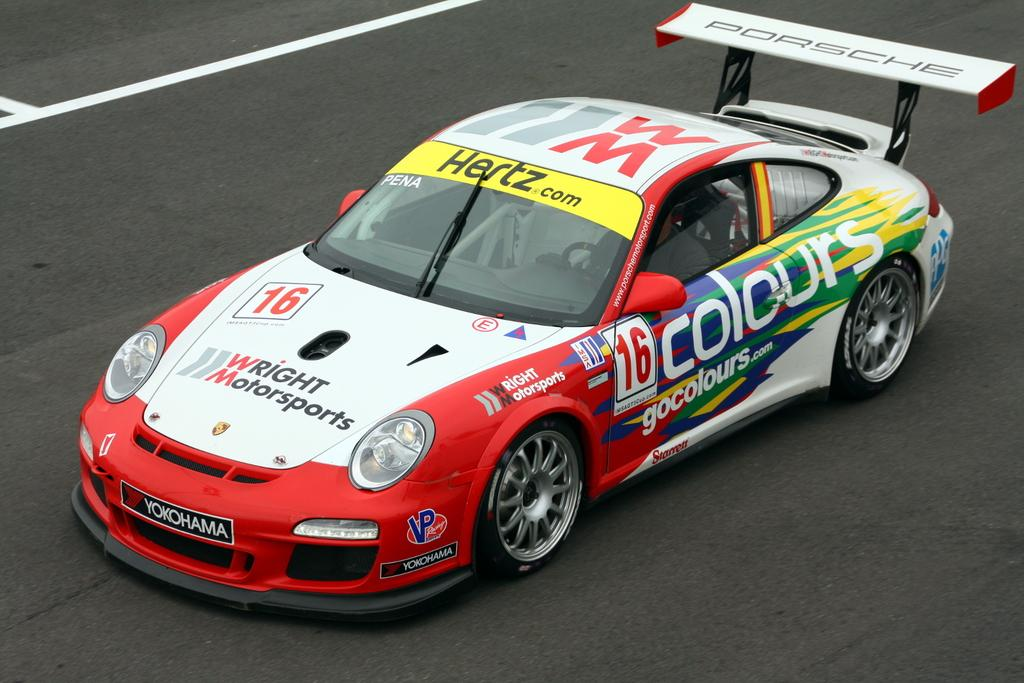What is the main subject of the image? The main subject of the image is a car. Where is the car located in the image? The car is on the road in the image. What additional detail can be observed on the car? There is text visible on the car. How many grapes are hanging from the car's rearview mirror in the image? There are no grapes visible in the image, and the car's rearview mirror is not mentioned in the provided facts. 